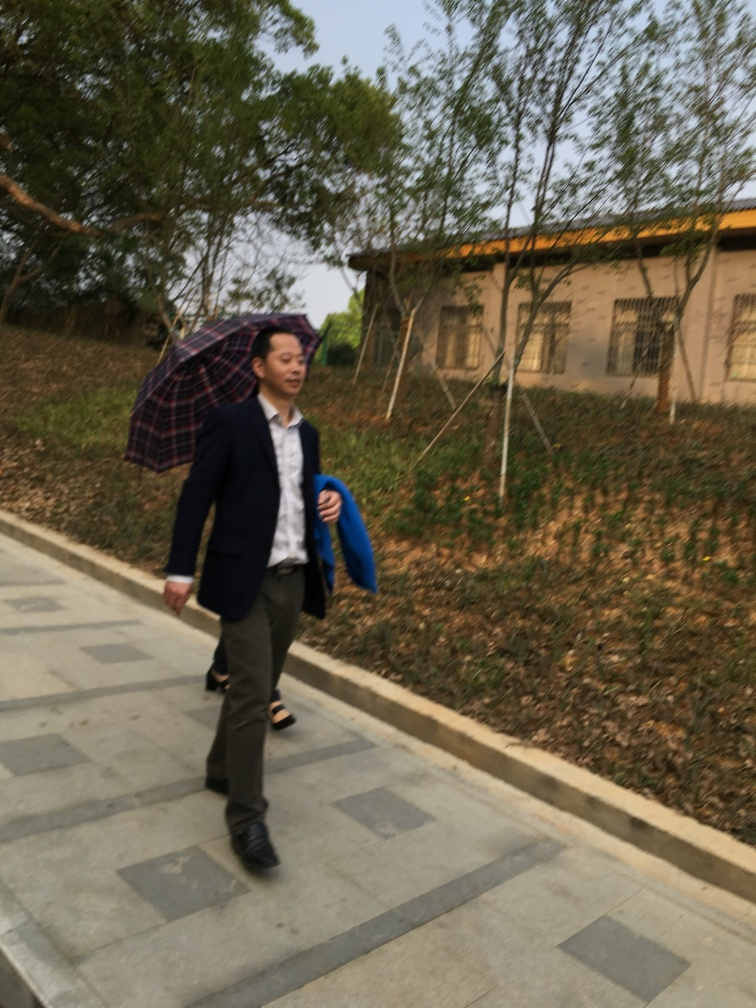Can you describe the weather in the image? The weather appears overcast with no strong sunlight or shadows visible. The person is carrying an umbrella, suggesting it might be raining or there is a likelihood of rain. 